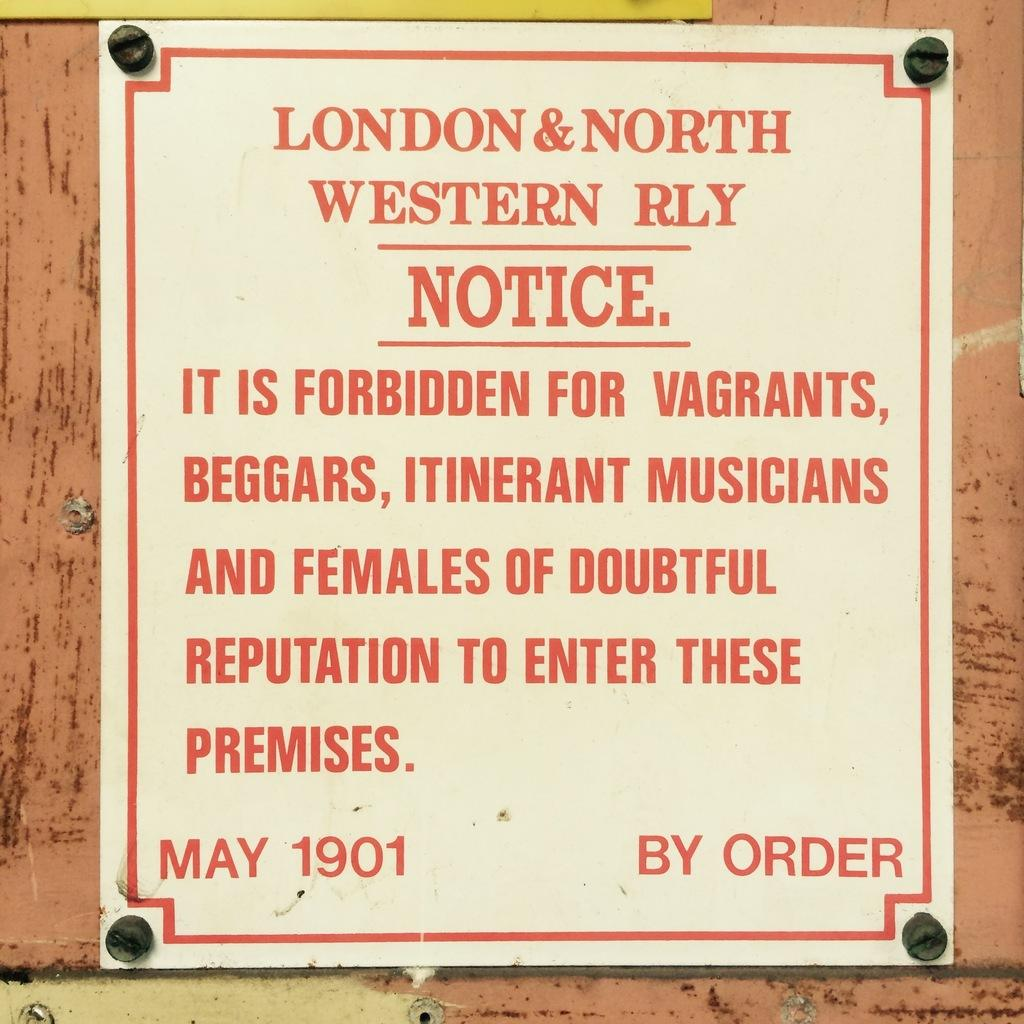What is on the wall in the image? There is a poster on the wall in the image. What is written on the poster? The poster says "London and north western rly." Where is the rabbit sitting in the image? There is no rabbit present in the image. What type of cable is connected to the poster in the image? There is no cable connected to the poster in the image. 